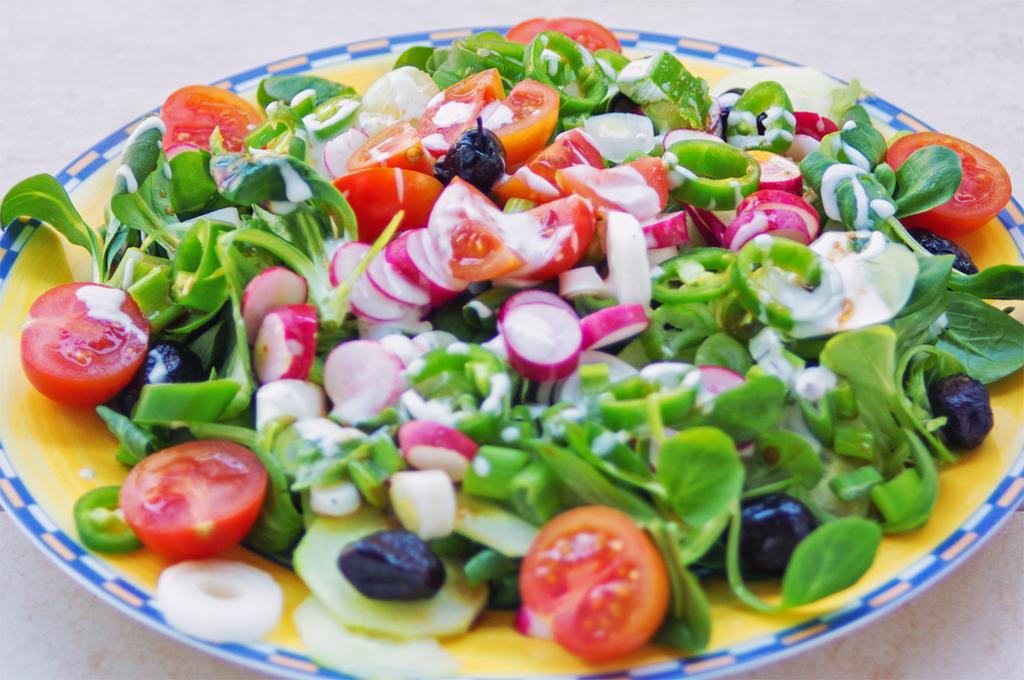What is on the plate that is visible in the image? There is food on a plate in the image. Where is the plate located in the image? The plate is placed on a table. What type of shame can be seen on the plate in the image? There is no shame present in the image; it is a plate of food. What type of vessel is used to serve the stew in the image? There is no stew present in the image, and therefore no vessel is used to serve it. 